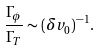Convert formula to latex. <formula><loc_0><loc_0><loc_500><loc_500>\frac { \Gamma _ { \phi } } { \Gamma _ { T } } \sim ( \delta v _ { 0 } ) ^ { - 1 } .</formula> 